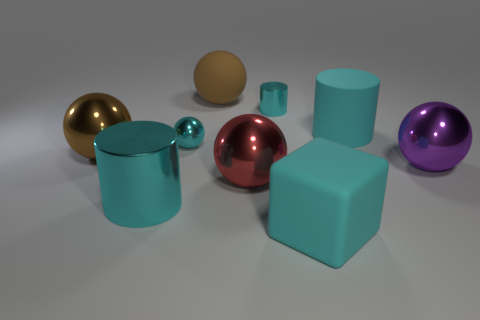Subtract all big cylinders. How many cylinders are left? 1 Subtract all purple balls. How many balls are left? 4 Subtract all cubes. How many objects are left? 8 Subtract all cyan cubes. How many green balls are left? 0 Subtract all balls. Subtract all tiny cyan shiny spheres. How many objects are left? 3 Add 2 red shiny objects. How many red shiny objects are left? 3 Add 8 brown spheres. How many brown spheres exist? 10 Subtract 0 gray cylinders. How many objects are left? 9 Subtract 1 cubes. How many cubes are left? 0 Subtract all yellow cylinders. Subtract all blue spheres. How many cylinders are left? 3 